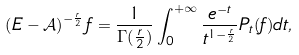Convert formula to latex. <formula><loc_0><loc_0><loc_500><loc_500>\left ( E - \mathcal { A } \right ) ^ { - \frac { r } { 2 } } f = \frac { 1 } { \Gamma ( \frac { r } { 2 } ) } \int _ { 0 } ^ { + \infty } \frac { e ^ { - t } } { t ^ { 1 - \frac { r } { 2 } } } P _ { t } ( f ) d t ,</formula> 